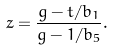Convert formula to latex. <formula><loc_0><loc_0><loc_500><loc_500>z = \frac { g - t / b _ { 1 } } { g - 1 / b _ { 5 } } .</formula> 